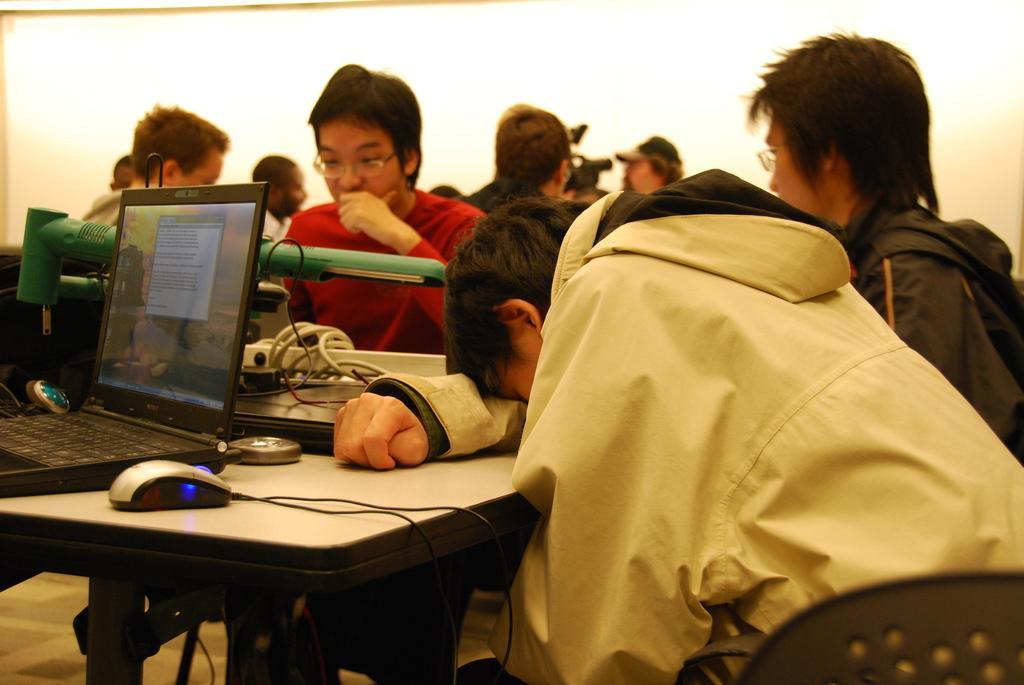Please provide a concise description of this image. In this image I can see number of people are sitting on chairs. Here on this table I can see a mouse and a laptop. 